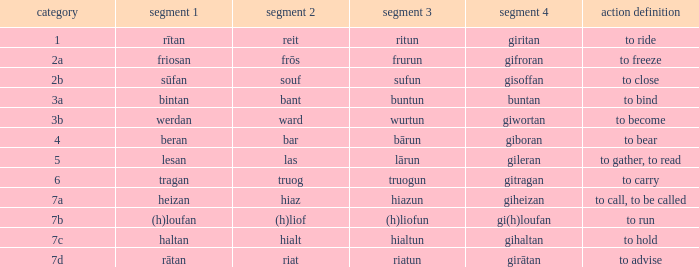What is the part 3 of the word in class 7a? Hiazun. 